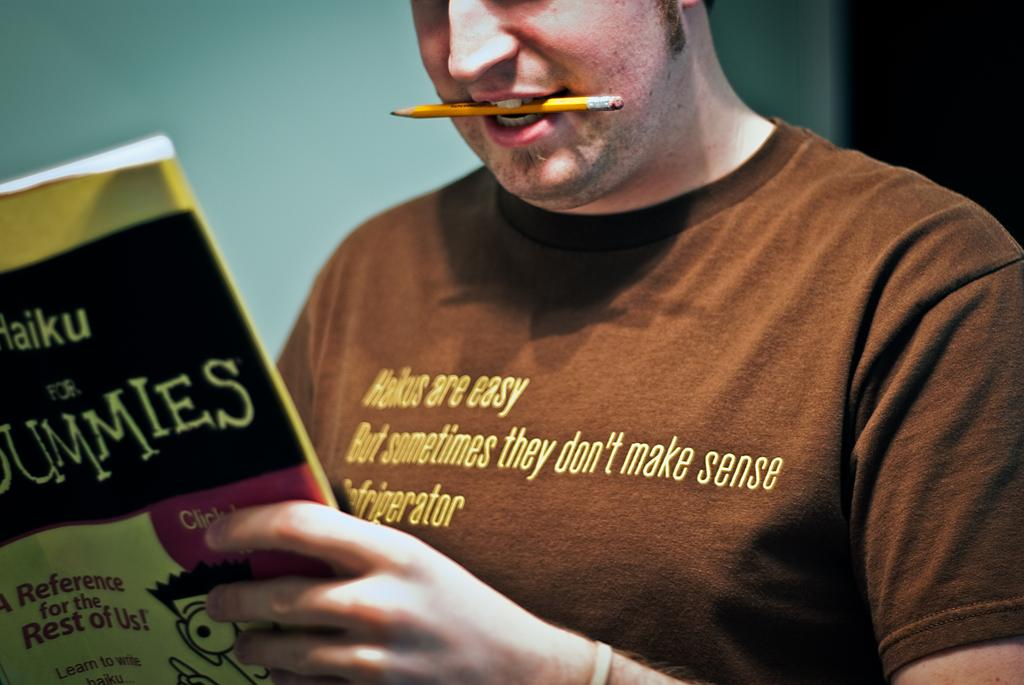Provide a one-sentence caption for the provided image. Man with a pencil in his mouse reading Haiku for Dummies. 